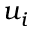<formula> <loc_0><loc_0><loc_500><loc_500>u _ { i }</formula> 